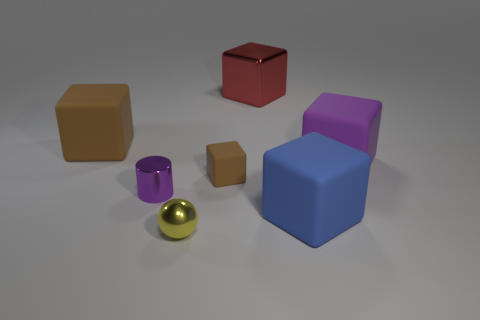Subtract all red blocks. How many blocks are left? 4 Subtract all gray blocks. Subtract all yellow spheres. How many blocks are left? 5 Add 3 big red shiny blocks. How many objects exist? 10 Subtract all cylinders. How many objects are left? 6 Subtract 0 purple spheres. How many objects are left? 7 Subtract all tiny blue objects. Subtract all big objects. How many objects are left? 3 Add 7 tiny purple cylinders. How many tiny purple cylinders are left? 8 Add 2 tiny purple things. How many tiny purple things exist? 3 